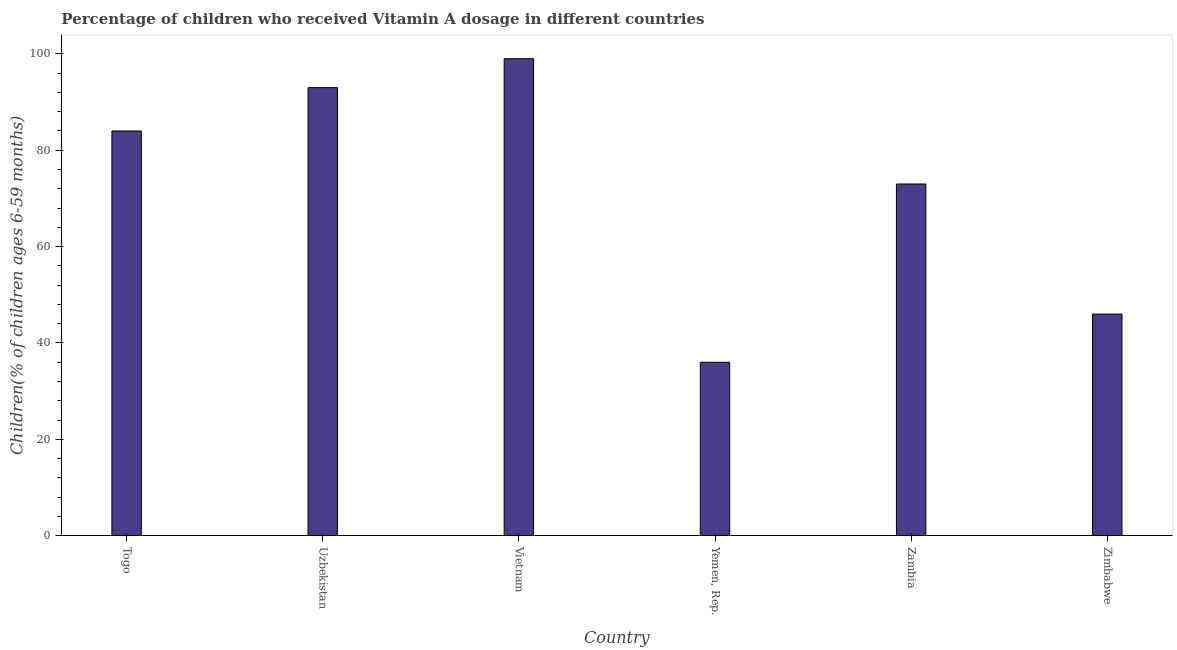What is the title of the graph?
Give a very brief answer. Percentage of children who received Vitamin A dosage in different countries. What is the label or title of the X-axis?
Provide a short and direct response. Country. What is the label or title of the Y-axis?
Keep it short and to the point. Children(% of children ages 6-59 months). Across all countries, what is the maximum vitamin a supplementation coverage rate?
Offer a very short reply. 99. In which country was the vitamin a supplementation coverage rate maximum?
Provide a short and direct response. Vietnam. In which country was the vitamin a supplementation coverage rate minimum?
Keep it short and to the point. Yemen, Rep. What is the sum of the vitamin a supplementation coverage rate?
Ensure brevity in your answer.  431. What is the difference between the vitamin a supplementation coverage rate in Vietnam and Zambia?
Offer a terse response. 26. What is the average vitamin a supplementation coverage rate per country?
Your response must be concise. 71.83. What is the median vitamin a supplementation coverage rate?
Offer a terse response. 78.5. What is the ratio of the vitamin a supplementation coverage rate in Uzbekistan to that in Zimbabwe?
Make the answer very short. 2.02. Is the difference between the vitamin a supplementation coverage rate in Togo and Vietnam greater than the difference between any two countries?
Make the answer very short. No. What is the difference between two consecutive major ticks on the Y-axis?
Make the answer very short. 20. Are the values on the major ticks of Y-axis written in scientific E-notation?
Your answer should be compact. No. What is the Children(% of children ages 6-59 months) in Togo?
Your answer should be very brief. 84. What is the Children(% of children ages 6-59 months) of Uzbekistan?
Your answer should be very brief. 93. What is the Children(% of children ages 6-59 months) of Zambia?
Make the answer very short. 73. What is the Children(% of children ages 6-59 months) in Zimbabwe?
Your answer should be compact. 46. What is the difference between the Children(% of children ages 6-59 months) in Togo and Uzbekistan?
Give a very brief answer. -9. What is the difference between the Children(% of children ages 6-59 months) in Togo and Vietnam?
Your answer should be compact. -15. What is the difference between the Children(% of children ages 6-59 months) in Togo and Yemen, Rep.?
Make the answer very short. 48. What is the difference between the Children(% of children ages 6-59 months) in Togo and Zambia?
Offer a very short reply. 11. What is the difference between the Children(% of children ages 6-59 months) in Togo and Zimbabwe?
Give a very brief answer. 38. What is the difference between the Children(% of children ages 6-59 months) in Uzbekistan and Vietnam?
Provide a succinct answer. -6. What is the difference between the Children(% of children ages 6-59 months) in Uzbekistan and Yemen, Rep.?
Keep it short and to the point. 57. What is the difference between the Children(% of children ages 6-59 months) in Uzbekistan and Zambia?
Ensure brevity in your answer.  20. What is the difference between the Children(% of children ages 6-59 months) in Uzbekistan and Zimbabwe?
Your answer should be compact. 47. What is the difference between the Children(% of children ages 6-59 months) in Vietnam and Zambia?
Offer a terse response. 26. What is the difference between the Children(% of children ages 6-59 months) in Vietnam and Zimbabwe?
Make the answer very short. 53. What is the difference between the Children(% of children ages 6-59 months) in Yemen, Rep. and Zambia?
Keep it short and to the point. -37. What is the difference between the Children(% of children ages 6-59 months) in Zambia and Zimbabwe?
Provide a succinct answer. 27. What is the ratio of the Children(% of children ages 6-59 months) in Togo to that in Uzbekistan?
Give a very brief answer. 0.9. What is the ratio of the Children(% of children ages 6-59 months) in Togo to that in Vietnam?
Keep it short and to the point. 0.85. What is the ratio of the Children(% of children ages 6-59 months) in Togo to that in Yemen, Rep.?
Provide a short and direct response. 2.33. What is the ratio of the Children(% of children ages 6-59 months) in Togo to that in Zambia?
Offer a very short reply. 1.15. What is the ratio of the Children(% of children ages 6-59 months) in Togo to that in Zimbabwe?
Give a very brief answer. 1.83. What is the ratio of the Children(% of children ages 6-59 months) in Uzbekistan to that in Vietnam?
Offer a very short reply. 0.94. What is the ratio of the Children(% of children ages 6-59 months) in Uzbekistan to that in Yemen, Rep.?
Your response must be concise. 2.58. What is the ratio of the Children(% of children ages 6-59 months) in Uzbekistan to that in Zambia?
Your response must be concise. 1.27. What is the ratio of the Children(% of children ages 6-59 months) in Uzbekistan to that in Zimbabwe?
Give a very brief answer. 2.02. What is the ratio of the Children(% of children ages 6-59 months) in Vietnam to that in Yemen, Rep.?
Offer a very short reply. 2.75. What is the ratio of the Children(% of children ages 6-59 months) in Vietnam to that in Zambia?
Provide a short and direct response. 1.36. What is the ratio of the Children(% of children ages 6-59 months) in Vietnam to that in Zimbabwe?
Provide a short and direct response. 2.15. What is the ratio of the Children(% of children ages 6-59 months) in Yemen, Rep. to that in Zambia?
Keep it short and to the point. 0.49. What is the ratio of the Children(% of children ages 6-59 months) in Yemen, Rep. to that in Zimbabwe?
Provide a short and direct response. 0.78. What is the ratio of the Children(% of children ages 6-59 months) in Zambia to that in Zimbabwe?
Your answer should be very brief. 1.59. 